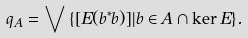Convert formula to latex. <formula><loc_0><loc_0><loc_500><loc_500>q _ { A } = \bigvee \, \{ [ E ( b ^ { * } b ) ] | b \in A \cap \ker E \} .</formula> 